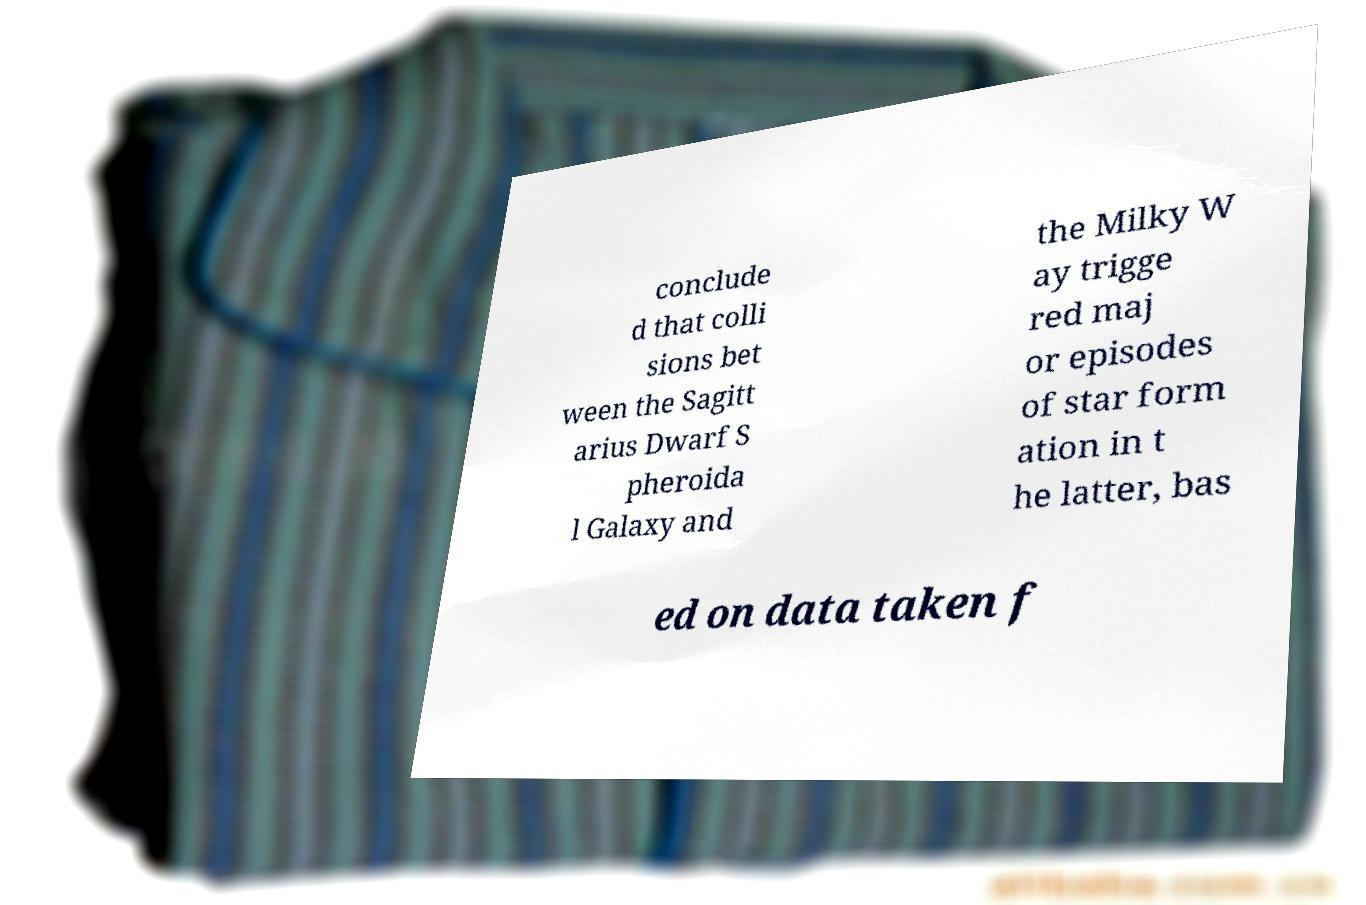Can you accurately transcribe the text from the provided image for me? conclude d that colli sions bet ween the Sagitt arius Dwarf S pheroida l Galaxy and the Milky W ay trigge red maj or episodes of star form ation in t he latter, bas ed on data taken f 